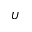<formula> <loc_0><loc_0><loc_500><loc_500>U</formula> 